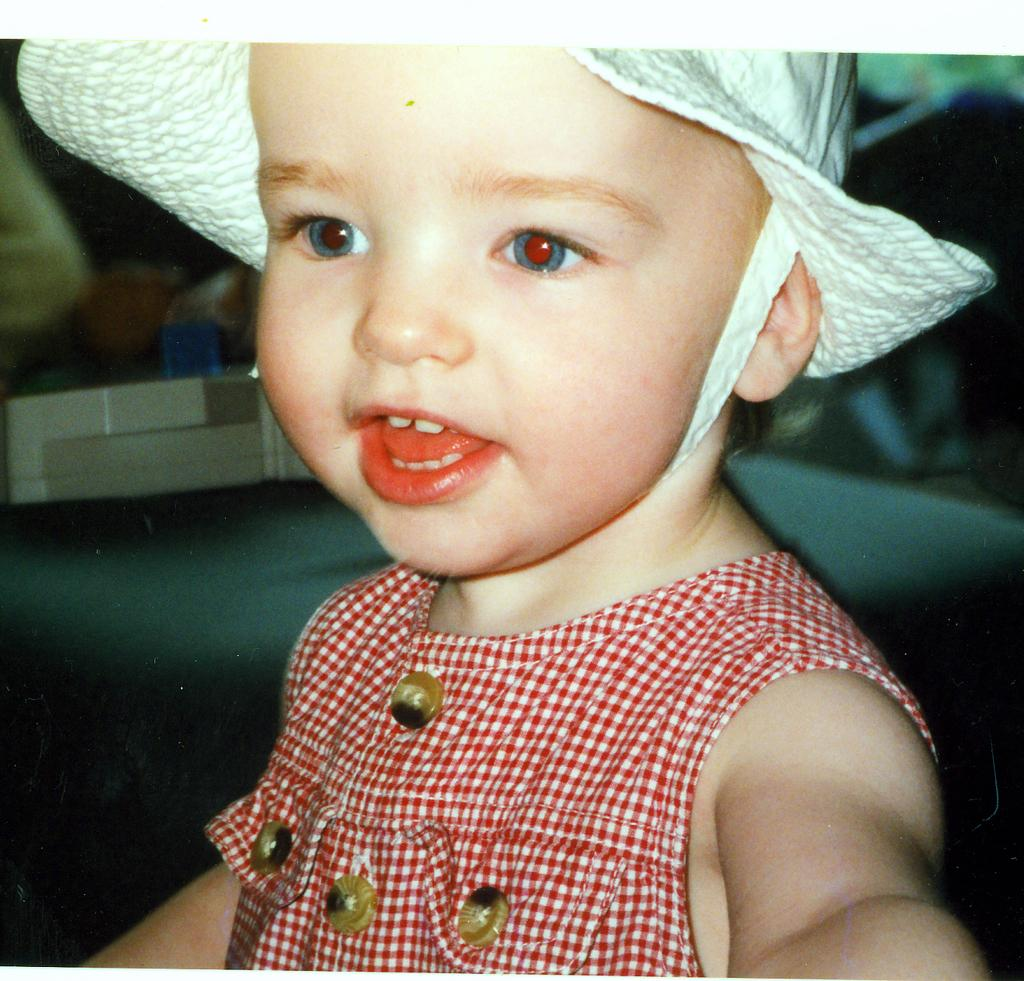What is the main subject of the image? The main subject of the image is a kid. What is the kid wearing on his head? The kid is wearing a hat on his head. What type of egg is the kid holding in the image? There is no egg present in the image; the kid is wearing a hat on his head. What role does the actor play in the image? There is no actor present in the image; the main subject is a kid wearing a hat. 